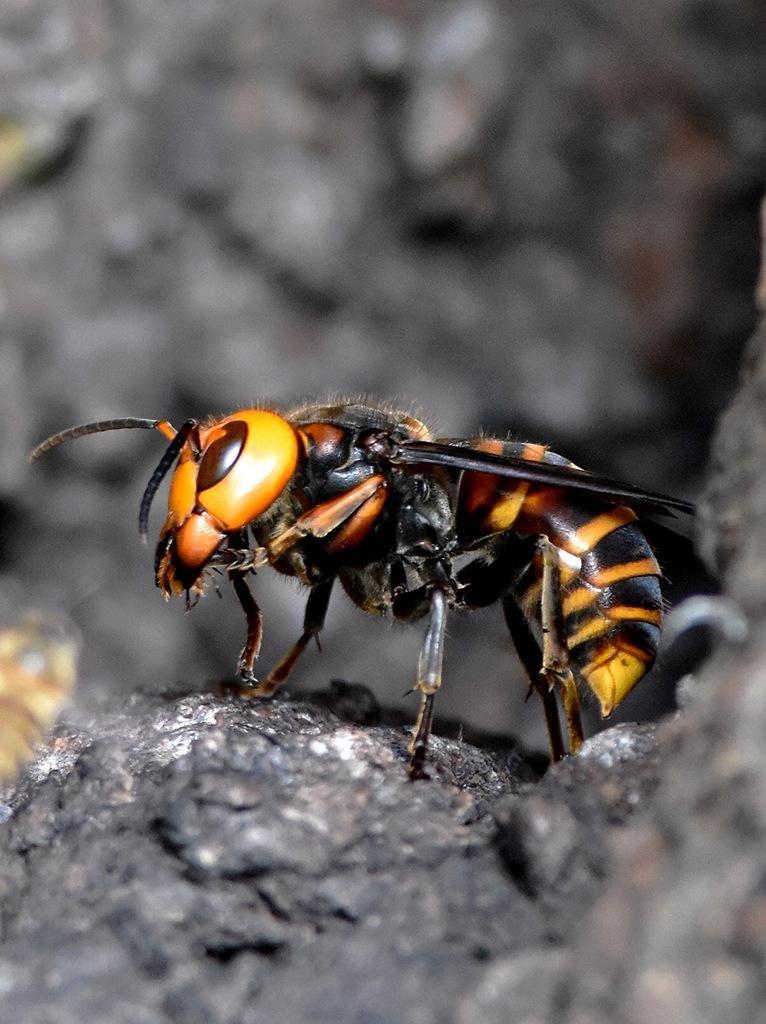Describe this image in one or two sentences. In this image we can see an insect which is on the rock. 